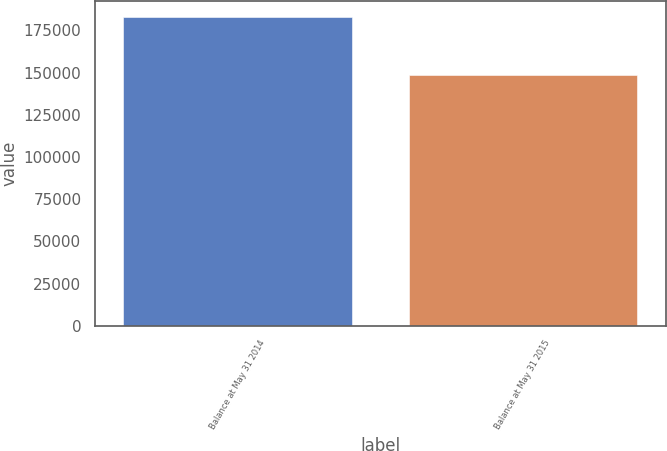<chart> <loc_0><loc_0><loc_500><loc_500><bar_chart><fcel>Balance at May 31 2014<fcel>Balance at May 31 2015<nl><fcel>183023<fcel>148742<nl></chart> 